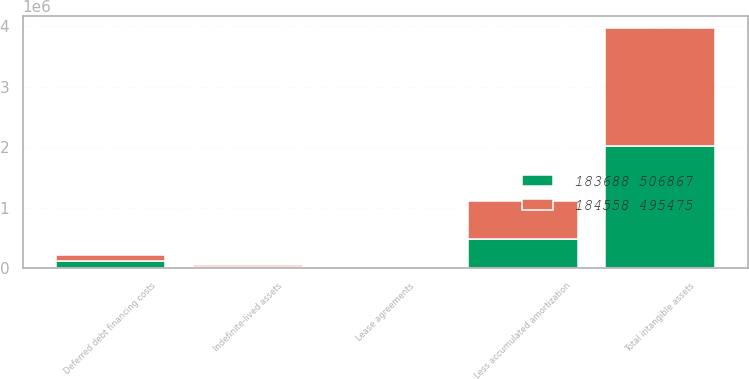Convert chart to OTSL. <chart><loc_0><loc_0><loc_500><loc_500><stacked_bar_chart><ecel><fcel>Lease agreements<fcel>Deferred debt financing costs<fcel>Indefinite-lived assets<fcel>Less accumulated amortization<fcel>Total intangible assets<nl><fcel>184558 495475<fcel>7982<fcel>101001<fcel>24818<fcel>621891<fcel>1.9495e+06<nl><fcel>183688 506867<fcel>8889<fcel>121872<fcel>22932<fcel>483773<fcel>2.02437e+06<nl></chart> 